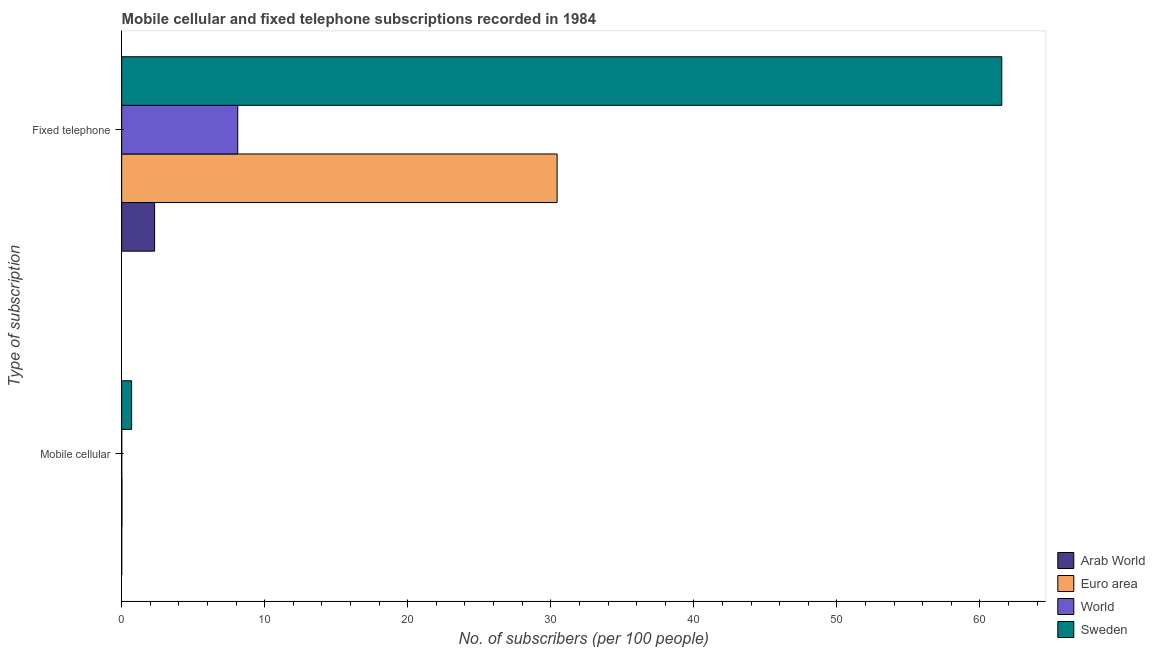Are the number of bars per tick equal to the number of legend labels?
Offer a very short reply. Yes. Are the number of bars on each tick of the Y-axis equal?
Ensure brevity in your answer.  Yes. How many bars are there on the 2nd tick from the top?
Your answer should be very brief. 4. What is the label of the 1st group of bars from the top?
Keep it short and to the point. Fixed telephone. What is the number of fixed telephone subscribers in Sweden?
Provide a succinct answer. 61.53. Across all countries, what is the maximum number of fixed telephone subscribers?
Your answer should be compact. 61.53. Across all countries, what is the minimum number of fixed telephone subscribers?
Provide a short and direct response. 2.3. In which country was the number of mobile cellular subscribers maximum?
Give a very brief answer. Sweden. In which country was the number of mobile cellular subscribers minimum?
Your answer should be compact. Arab World. What is the total number of mobile cellular subscribers in the graph?
Ensure brevity in your answer.  0.73. What is the difference between the number of fixed telephone subscribers in Arab World and that in Euro area?
Provide a succinct answer. -28.14. What is the difference between the number of mobile cellular subscribers in Euro area and the number of fixed telephone subscribers in Arab World?
Your answer should be compact. -2.28. What is the average number of fixed telephone subscribers per country?
Your response must be concise. 25.6. What is the difference between the number of mobile cellular subscribers and number of fixed telephone subscribers in World?
Ensure brevity in your answer.  -8.11. What is the ratio of the number of fixed telephone subscribers in Sweden to that in Euro area?
Your answer should be very brief. 2.02. Is the number of mobile cellular subscribers in Arab World less than that in Sweden?
Your answer should be compact. Yes. What does the 1st bar from the top in Fixed telephone represents?
Your response must be concise. Sweden. What does the 4th bar from the bottom in Mobile cellular represents?
Your answer should be very brief. Sweden. How many bars are there?
Provide a short and direct response. 8. How many countries are there in the graph?
Make the answer very short. 4. What is the difference between two consecutive major ticks on the X-axis?
Provide a succinct answer. 10. Where does the legend appear in the graph?
Your answer should be compact. Bottom right. How many legend labels are there?
Your answer should be very brief. 4. What is the title of the graph?
Give a very brief answer. Mobile cellular and fixed telephone subscriptions recorded in 1984. What is the label or title of the X-axis?
Keep it short and to the point. No. of subscribers (per 100 people). What is the label or title of the Y-axis?
Your answer should be very brief. Type of subscription. What is the No. of subscribers (per 100 people) in Arab World in Mobile cellular?
Offer a terse response. 0. What is the No. of subscribers (per 100 people) of Euro area in Mobile cellular?
Your answer should be very brief. 0.02. What is the No. of subscribers (per 100 people) in World in Mobile cellular?
Offer a terse response. 0.01. What is the No. of subscribers (per 100 people) in Sweden in Mobile cellular?
Ensure brevity in your answer.  0.69. What is the No. of subscribers (per 100 people) of Arab World in Fixed telephone?
Offer a terse response. 2.3. What is the No. of subscribers (per 100 people) in Euro area in Fixed telephone?
Offer a very short reply. 30.44. What is the No. of subscribers (per 100 people) of World in Fixed telephone?
Provide a short and direct response. 8.11. What is the No. of subscribers (per 100 people) in Sweden in Fixed telephone?
Ensure brevity in your answer.  61.53. Across all Type of subscription, what is the maximum No. of subscribers (per 100 people) of Arab World?
Offer a very short reply. 2.3. Across all Type of subscription, what is the maximum No. of subscribers (per 100 people) in Euro area?
Make the answer very short. 30.44. Across all Type of subscription, what is the maximum No. of subscribers (per 100 people) of World?
Offer a terse response. 8.11. Across all Type of subscription, what is the maximum No. of subscribers (per 100 people) of Sweden?
Your answer should be compact. 61.53. Across all Type of subscription, what is the minimum No. of subscribers (per 100 people) in Arab World?
Keep it short and to the point. 0. Across all Type of subscription, what is the minimum No. of subscribers (per 100 people) in Euro area?
Keep it short and to the point. 0.02. Across all Type of subscription, what is the minimum No. of subscribers (per 100 people) of World?
Provide a short and direct response. 0.01. Across all Type of subscription, what is the minimum No. of subscribers (per 100 people) of Sweden?
Give a very brief answer. 0.69. What is the total No. of subscribers (per 100 people) of Arab World in the graph?
Offer a very short reply. 2.3. What is the total No. of subscribers (per 100 people) of Euro area in the graph?
Provide a short and direct response. 30.46. What is the total No. of subscribers (per 100 people) of World in the graph?
Make the answer very short. 8.12. What is the total No. of subscribers (per 100 people) of Sweden in the graph?
Your response must be concise. 62.22. What is the difference between the No. of subscribers (per 100 people) of Arab World in Mobile cellular and that in Fixed telephone?
Give a very brief answer. -2.3. What is the difference between the No. of subscribers (per 100 people) of Euro area in Mobile cellular and that in Fixed telephone?
Offer a very short reply. -30.42. What is the difference between the No. of subscribers (per 100 people) of World in Mobile cellular and that in Fixed telephone?
Give a very brief answer. -8.11. What is the difference between the No. of subscribers (per 100 people) of Sweden in Mobile cellular and that in Fixed telephone?
Give a very brief answer. -60.83. What is the difference between the No. of subscribers (per 100 people) in Arab World in Mobile cellular and the No. of subscribers (per 100 people) in Euro area in Fixed telephone?
Your response must be concise. -30.44. What is the difference between the No. of subscribers (per 100 people) of Arab World in Mobile cellular and the No. of subscribers (per 100 people) of World in Fixed telephone?
Your answer should be compact. -8.11. What is the difference between the No. of subscribers (per 100 people) of Arab World in Mobile cellular and the No. of subscribers (per 100 people) of Sweden in Fixed telephone?
Offer a terse response. -61.52. What is the difference between the No. of subscribers (per 100 people) of Euro area in Mobile cellular and the No. of subscribers (per 100 people) of World in Fixed telephone?
Your answer should be very brief. -8.09. What is the difference between the No. of subscribers (per 100 people) in Euro area in Mobile cellular and the No. of subscribers (per 100 people) in Sweden in Fixed telephone?
Your answer should be very brief. -61.51. What is the difference between the No. of subscribers (per 100 people) in World in Mobile cellular and the No. of subscribers (per 100 people) in Sweden in Fixed telephone?
Your response must be concise. -61.52. What is the average No. of subscribers (per 100 people) in Arab World per Type of subscription?
Make the answer very short. 1.15. What is the average No. of subscribers (per 100 people) of Euro area per Type of subscription?
Offer a very short reply. 15.23. What is the average No. of subscribers (per 100 people) in World per Type of subscription?
Offer a terse response. 4.06. What is the average No. of subscribers (per 100 people) in Sweden per Type of subscription?
Ensure brevity in your answer.  31.11. What is the difference between the No. of subscribers (per 100 people) in Arab World and No. of subscribers (per 100 people) in Euro area in Mobile cellular?
Keep it short and to the point. -0.02. What is the difference between the No. of subscribers (per 100 people) in Arab World and No. of subscribers (per 100 people) in World in Mobile cellular?
Provide a short and direct response. -0. What is the difference between the No. of subscribers (per 100 people) in Arab World and No. of subscribers (per 100 people) in Sweden in Mobile cellular?
Ensure brevity in your answer.  -0.69. What is the difference between the No. of subscribers (per 100 people) in Euro area and No. of subscribers (per 100 people) in World in Mobile cellular?
Provide a short and direct response. 0.01. What is the difference between the No. of subscribers (per 100 people) of Euro area and No. of subscribers (per 100 people) of Sweden in Mobile cellular?
Keep it short and to the point. -0.67. What is the difference between the No. of subscribers (per 100 people) in World and No. of subscribers (per 100 people) in Sweden in Mobile cellular?
Ensure brevity in your answer.  -0.69. What is the difference between the No. of subscribers (per 100 people) in Arab World and No. of subscribers (per 100 people) in Euro area in Fixed telephone?
Keep it short and to the point. -28.14. What is the difference between the No. of subscribers (per 100 people) of Arab World and No. of subscribers (per 100 people) of World in Fixed telephone?
Offer a terse response. -5.81. What is the difference between the No. of subscribers (per 100 people) of Arab World and No. of subscribers (per 100 people) of Sweden in Fixed telephone?
Your response must be concise. -59.23. What is the difference between the No. of subscribers (per 100 people) in Euro area and No. of subscribers (per 100 people) in World in Fixed telephone?
Ensure brevity in your answer.  22.33. What is the difference between the No. of subscribers (per 100 people) in Euro area and No. of subscribers (per 100 people) in Sweden in Fixed telephone?
Your response must be concise. -31.09. What is the difference between the No. of subscribers (per 100 people) of World and No. of subscribers (per 100 people) of Sweden in Fixed telephone?
Offer a very short reply. -53.41. What is the ratio of the No. of subscribers (per 100 people) in Arab World in Mobile cellular to that in Fixed telephone?
Provide a short and direct response. 0. What is the ratio of the No. of subscribers (per 100 people) of Euro area in Mobile cellular to that in Fixed telephone?
Keep it short and to the point. 0. What is the ratio of the No. of subscribers (per 100 people) of World in Mobile cellular to that in Fixed telephone?
Offer a very short reply. 0. What is the ratio of the No. of subscribers (per 100 people) in Sweden in Mobile cellular to that in Fixed telephone?
Make the answer very short. 0.01. What is the difference between the highest and the second highest No. of subscribers (per 100 people) in Arab World?
Give a very brief answer. 2.3. What is the difference between the highest and the second highest No. of subscribers (per 100 people) of Euro area?
Keep it short and to the point. 30.42. What is the difference between the highest and the second highest No. of subscribers (per 100 people) of World?
Make the answer very short. 8.11. What is the difference between the highest and the second highest No. of subscribers (per 100 people) in Sweden?
Provide a succinct answer. 60.83. What is the difference between the highest and the lowest No. of subscribers (per 100 people) in Arab World?
Your response must be concise. 2.3. What is the difference between the highest and the lowest No. of subscribers (per 100 people) in Euro area?
Your answer should be very brief. 30.42. What is the difference between the highest and the lowest No. of subscribers (per 100 people) in World?
Your answer should be compact. 8.11. What is the difference between the highest and the lowest No. of subscribers (per 100 people) of Sweden?
Offer a very short reply. 60.83. 